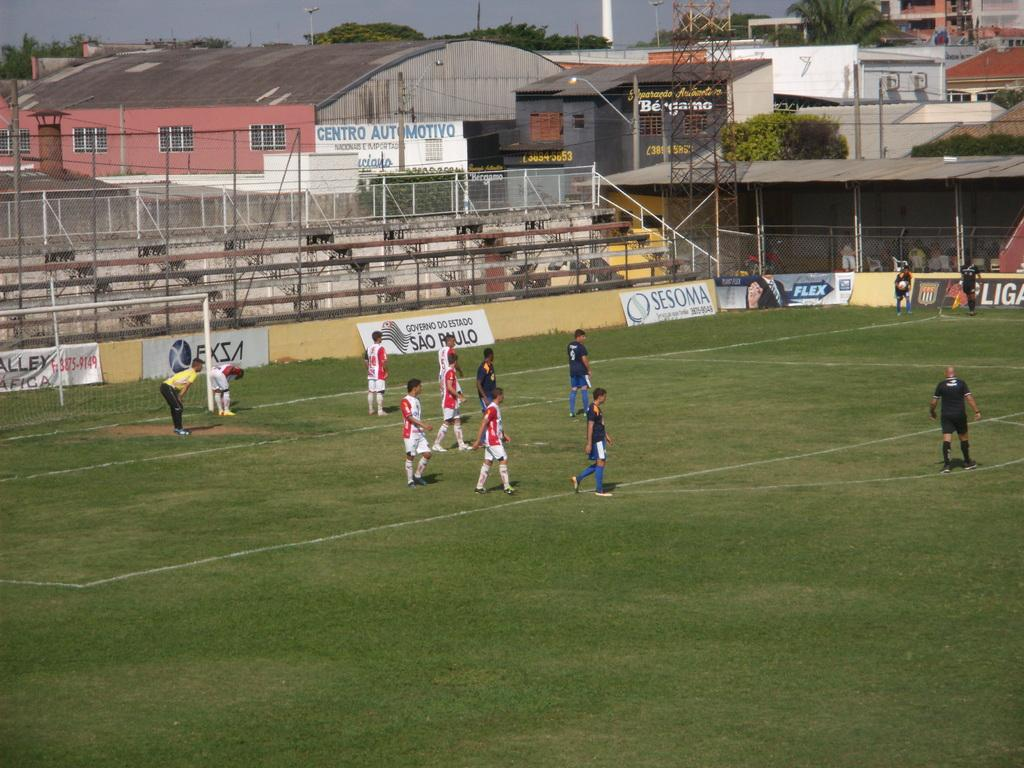<image>
Render a clear and concise summary of the photo. The blue and white ad is for the Flex company 